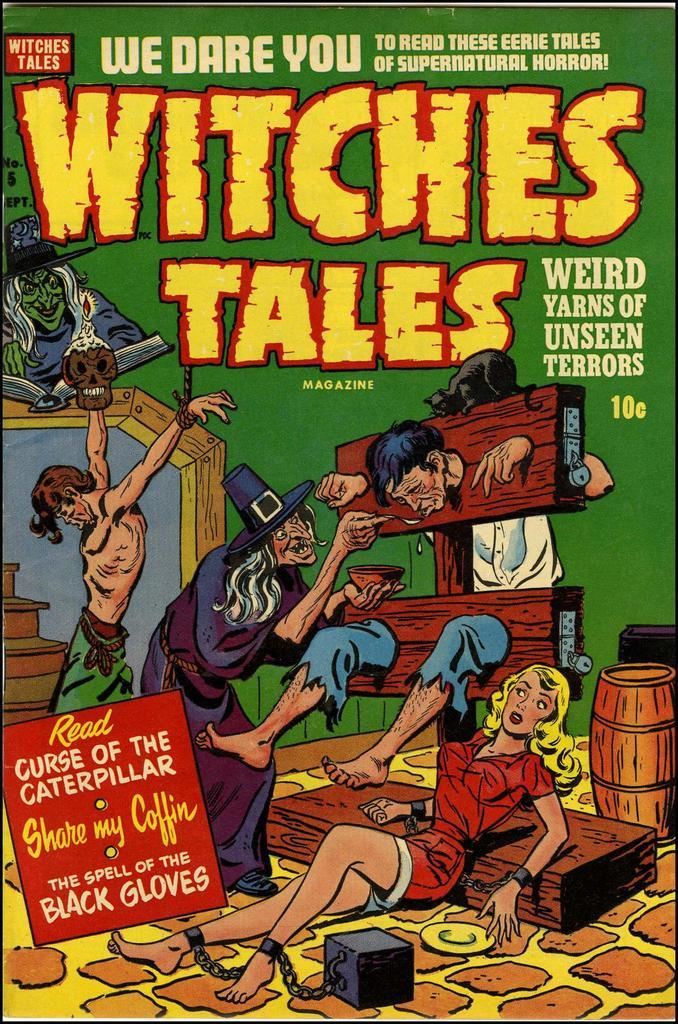Provide a one-sentence caption for the provided image. The front cover of Witches Tales has a person in a stockade. 